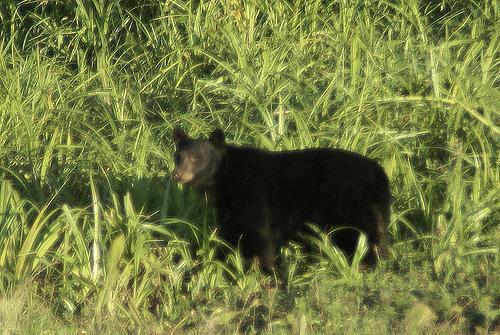How many bears are on the grass?
Give a very brief answer. 1. 